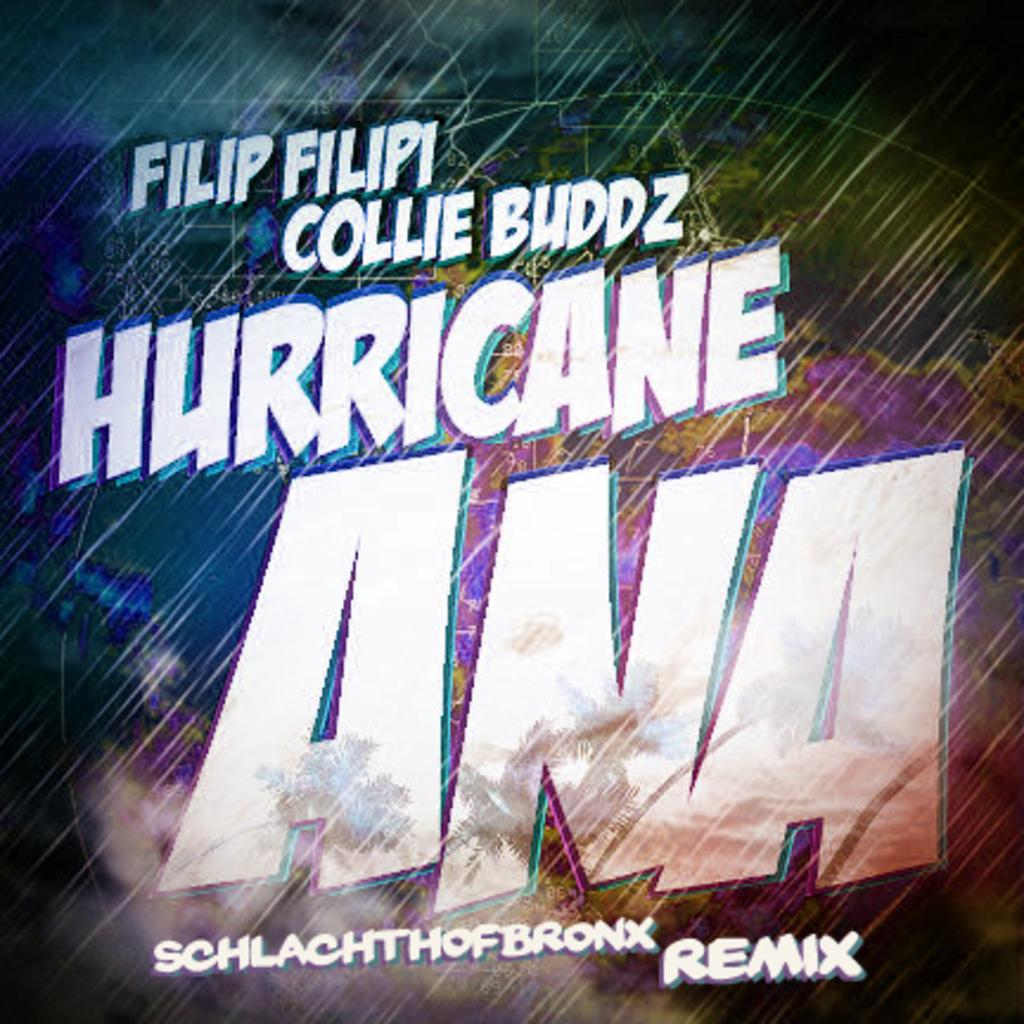Provide a one-sentence caption for the provided image. The cover an album entitled Hurricane Ana Remix. 